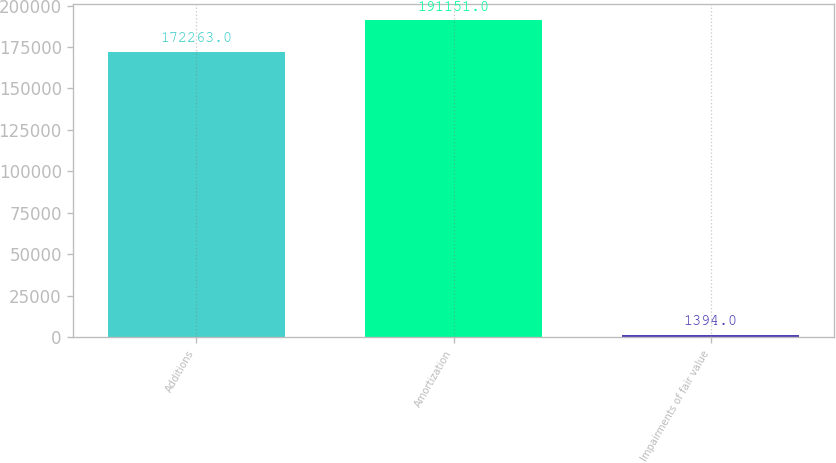<chart> <loc_0><loc_0><loc_500><loc_500><bar_chart><fcel>Additions<fcel>Amortization<fcel>Impairments of fair value<nl><fcel>172263<fcel>191151<fcel>1394<nl></chart> 